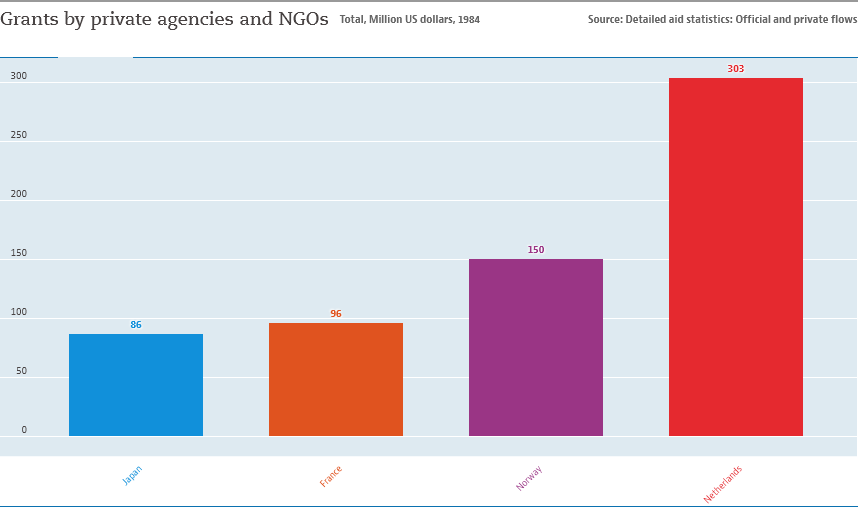Point out several critical features in this image. The value of the rightmost bar is 303. 